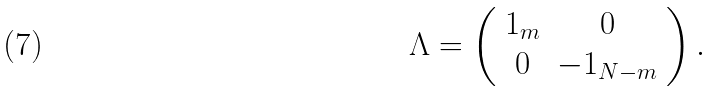Convert formula to latex. <formula><loc_0><loc_0><loc_500><loc_500>\Lambda = \left ( \begin{array} { c c } 1 _ { m } & 0 \\ 0 & - 1 _ { N - m } \end{array} \right ) .</formula> 